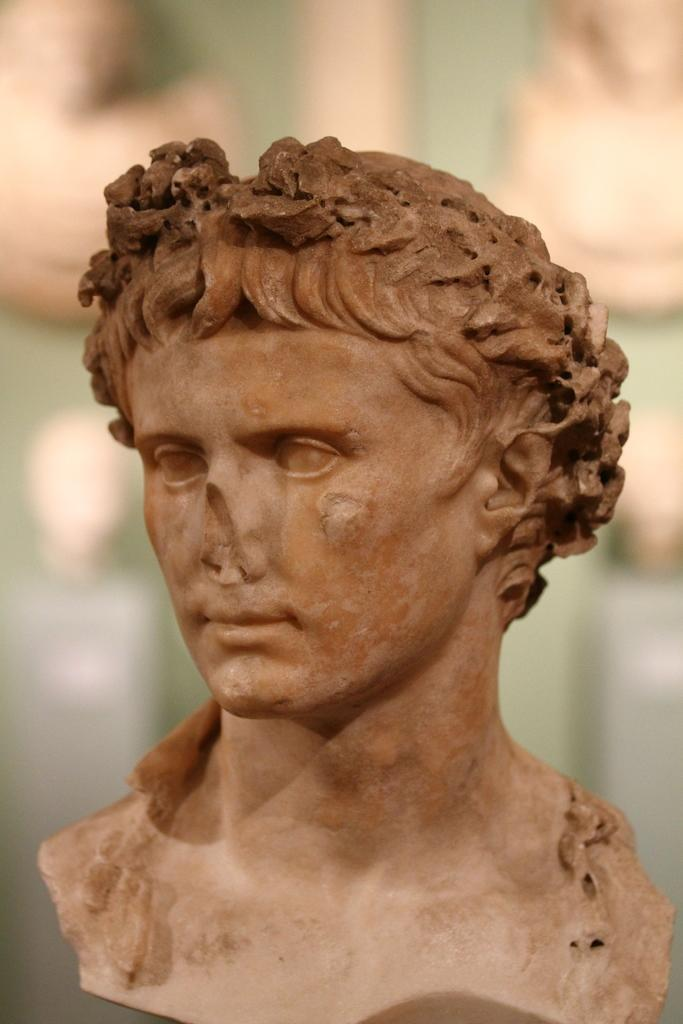What is the main subject of the image? There is a sculpture in the image. Can you describe the background of the image? The background of the image is blurred. What type of border is depicted around the sculpture in the image? There is no border depicted around the sculpture in the image. Where is the nearest store to the sculpture in the image? The provided facts do not give any information about the location of a store in relation to the sculpture. 